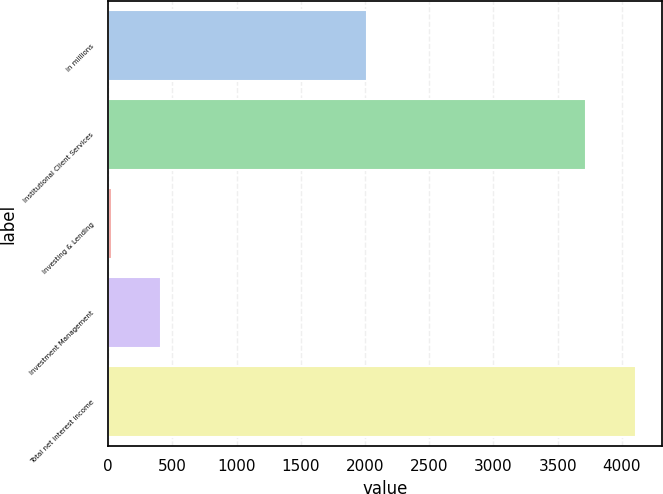Convert chart to OTSL. <chart><loc_0><loc_0><loc_500><loc_500><bar_chart><fcel>in millions<fcel>Institutional Client Services<fcel>Investing & Lending<fcel>Investment Management<fcel>Total net interest income<nl><fcel>2012<fcel>3723<fcel>26<fcel>411.4<fcel>4108.4<nl></chart> 